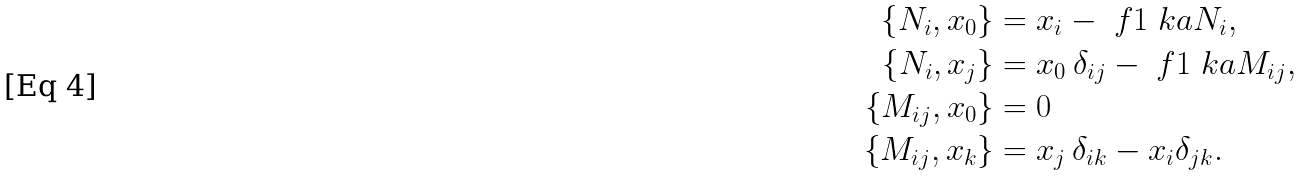Convert formula to latex. <formula><loc_0><loc_0><loc_500><loc_500>\{ N _ { i } , x _ { 0 } \} & = x _ { i } - \ f { 1 } { \ k a } N _ { i } , \\ \{ N _ { i } , x _ { j } \} & = x _ { 0 } \, \delta _ { i j } - \ f { 1 } { \ k a } M _ { i j } , \\ \left \{ M _ { i j } , x _ { 0 } \right \} & = 0 \\ \left \{ M _ { i j } , x _ { k } \right \} & = x _ { j } \, \delta _ { i k } - x _ { i } \delta _ { j k } .</formula> 